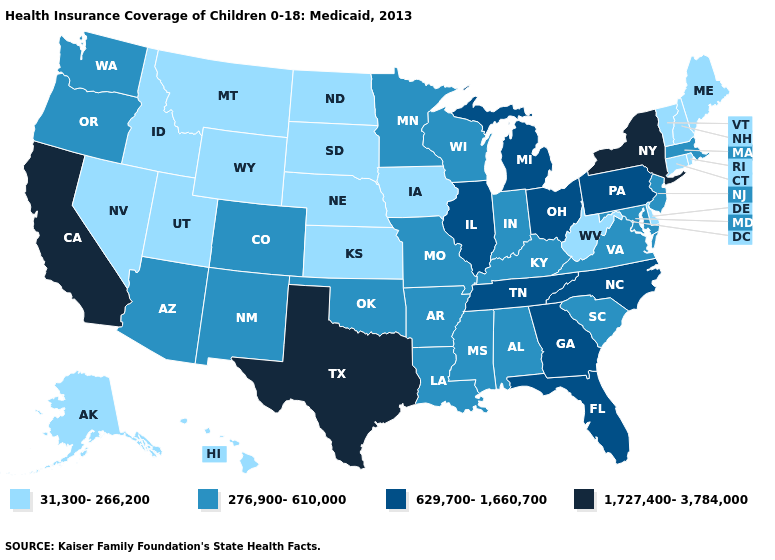Does New Mexico have the lowest value in the West?
Concise answer only. No. Name the states that have a value in the range 31,300-266,200?
Short answer required. Alaska, Connecticut, Delaware, Hawaii, Idaho, Iowa, Kansas, Maine, Montana, Nebraska, Nevada, New Hampshire, North Dakota, Rhode Island, South Dakota, Utah, Vermont, West Virginia, Wyoming. Among the states that border Missouri , which have the lowest value?
Be succinct. Iowa, Kansas, Nebraska. What is the value of Minnesota?
Concise answer only. 276,900-610,000. Name the states that have a value in the range 1,727,400-3,784,000?
Short answer required. California, New York, Texas. Does New Jersey have the highest value in the USA?
Answer briefly. No. Does Nebraska have the lowest value in the USA?
Write a very short answer. Yes. What is the lowest value in states that border North Dakota?
Write a very short answer. 31,300-266,200. What is the value of West Virginia?
Keep it brief. 31,300-266,200. What is the value of New Jersey?
Be succinct. 276,900-610,000. Name the states that have a value in the range 31,300-266,200?
Answer briefly. Alaska, Connecticut, Delaware, Hawaii, Idaho, Iowa, Kansas, Maine, Montana, Nebraska, Nevada, New Hampshire, North Dakota, Rhode Island, South Dakota, Utah, Vermont, West Virginia, Wyoming. What is the value of Wyoming?
Quick response, please. 31,300-266,200. What is the value of Florida?
Keep it brief. 629,700-1,660,700. 